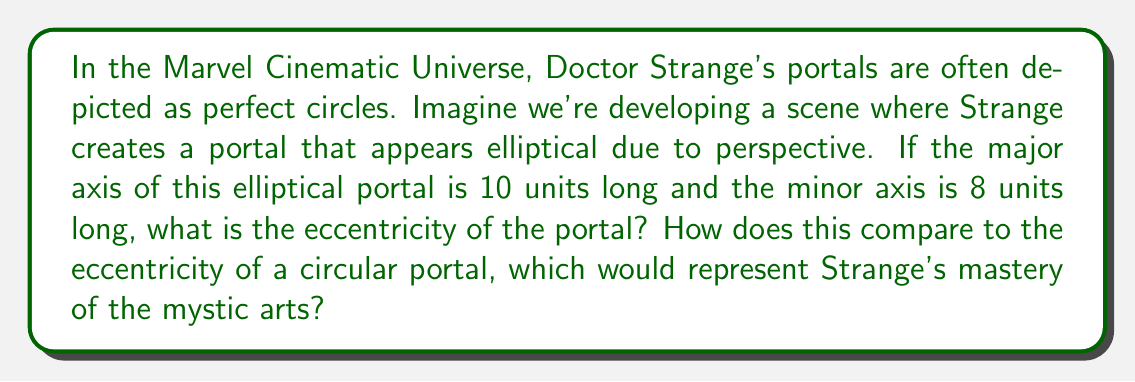Give your solution to this math problem. Let's approach this step-by-step, comparing the elliptical portal to a perfect circle:

1) For an ellipse, the eccentricity ($e$) is given by the formula:

   $$e = \sqrt{1 - \frac{b^2}{a^2}}$$

   where $a$ is the length of the semi-major axis and $b$ is the length of the semi-minor axis.

2) We're given that the major axis is 10 units and the minor axis is 8 units. So:
   $a = 5$ (half of 10)
   $b = 4$ (half of 8)

3) Plugging these values into our equation:

   $$e = \sqrt{1 - \frac{4^2}{5^2}} = \sqrt{1 - \frac{16}{25}}$$

4) Simplifying:

   $$e = \sqrt{\frac{25-16}{25}} = \sqrt{\frac{9}{25}} = \frac{3}{5} = 0.6$$

5) For a perfect circle, $a = b$, so the eccentricity would be:

   $$e_{circle} = \sqrt{1 - \frac{a^2}{a^2}} = \sqrt{1-1} = 0$$

6) Comparing the two:
   - Elliptical portal: $e = 0.6$
   - Circular portal: $e = 0$

The elliptical portal has a higher eccentricity, deviating from the perfect circle that would represent Strange's mastery.
Answer: $e = 0.6$ 